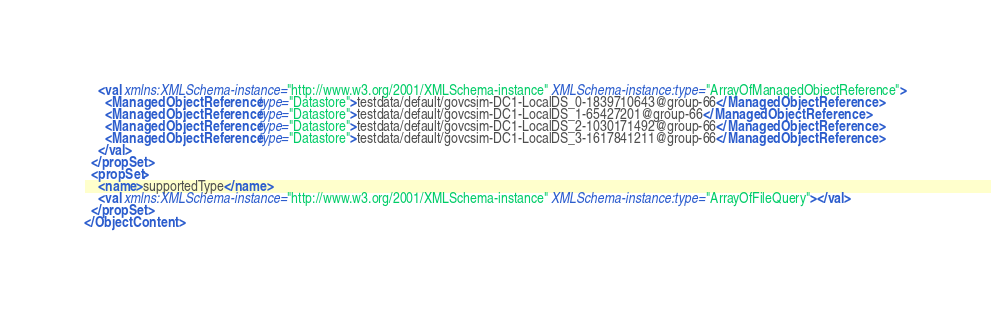<code> <loc_0><loc_0><loc_500><loc_500><_XML_>    <val xmlns:XMLSchema-instance="http://www.w3.org/2001/XMLSchema-instance" XMLSchema-instance:type="ArrayOfManagedObjectReference">
      <ManagedObjectReference type="Datastore">testdata/default/govcsim-DC1-LocalDS_0-1839710643@group-66</ManagedObjectReference>
      <ManagedObjectReference type="Datastore">testdata/default/govcsim-DC1-LocalDS_1-65427201@group-66</ManagedObjectReference>
      <ManagedObjectReference type="Datastore">testdata/default/govcsim-DC1-LocalDS_2-1030171492@group-66</ManagedObjectReference>
      <ManagedObjectReference type="Datastore">testdata/default/govcsim-DC1-LocalDS_3-1617841211@group-66</ManagedObjectReference>
    </val>
  </propSet>
  <propSet>
    <name>supportedType</name>
    <val xmlns:XMLSchema-instance="http://www.w3.org/2001/XMLSchema-instance" XMLSchema-instance:type="ArrayOfFileQuery"></val>
  </propSet>
</ObjectContent></code> 